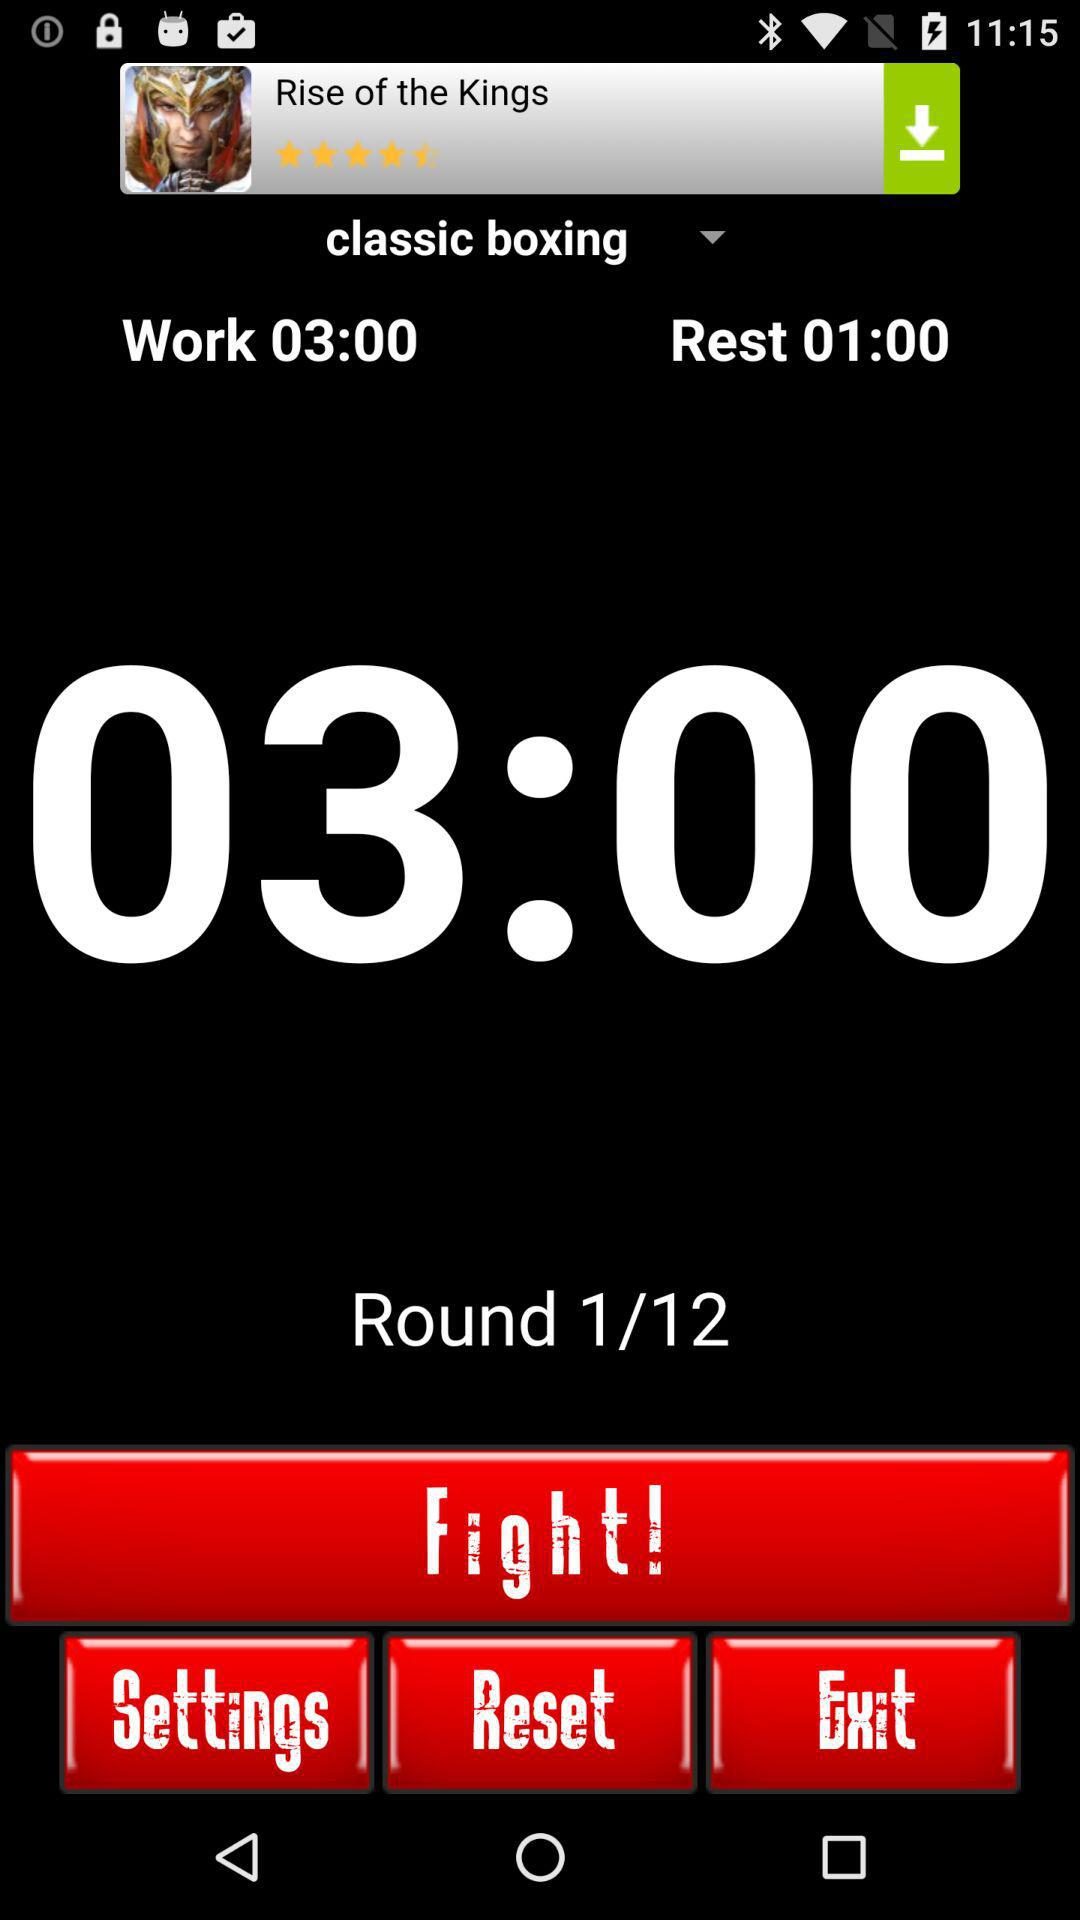What is the rest duration in classic boxing? The rest duration is 1 minute. 